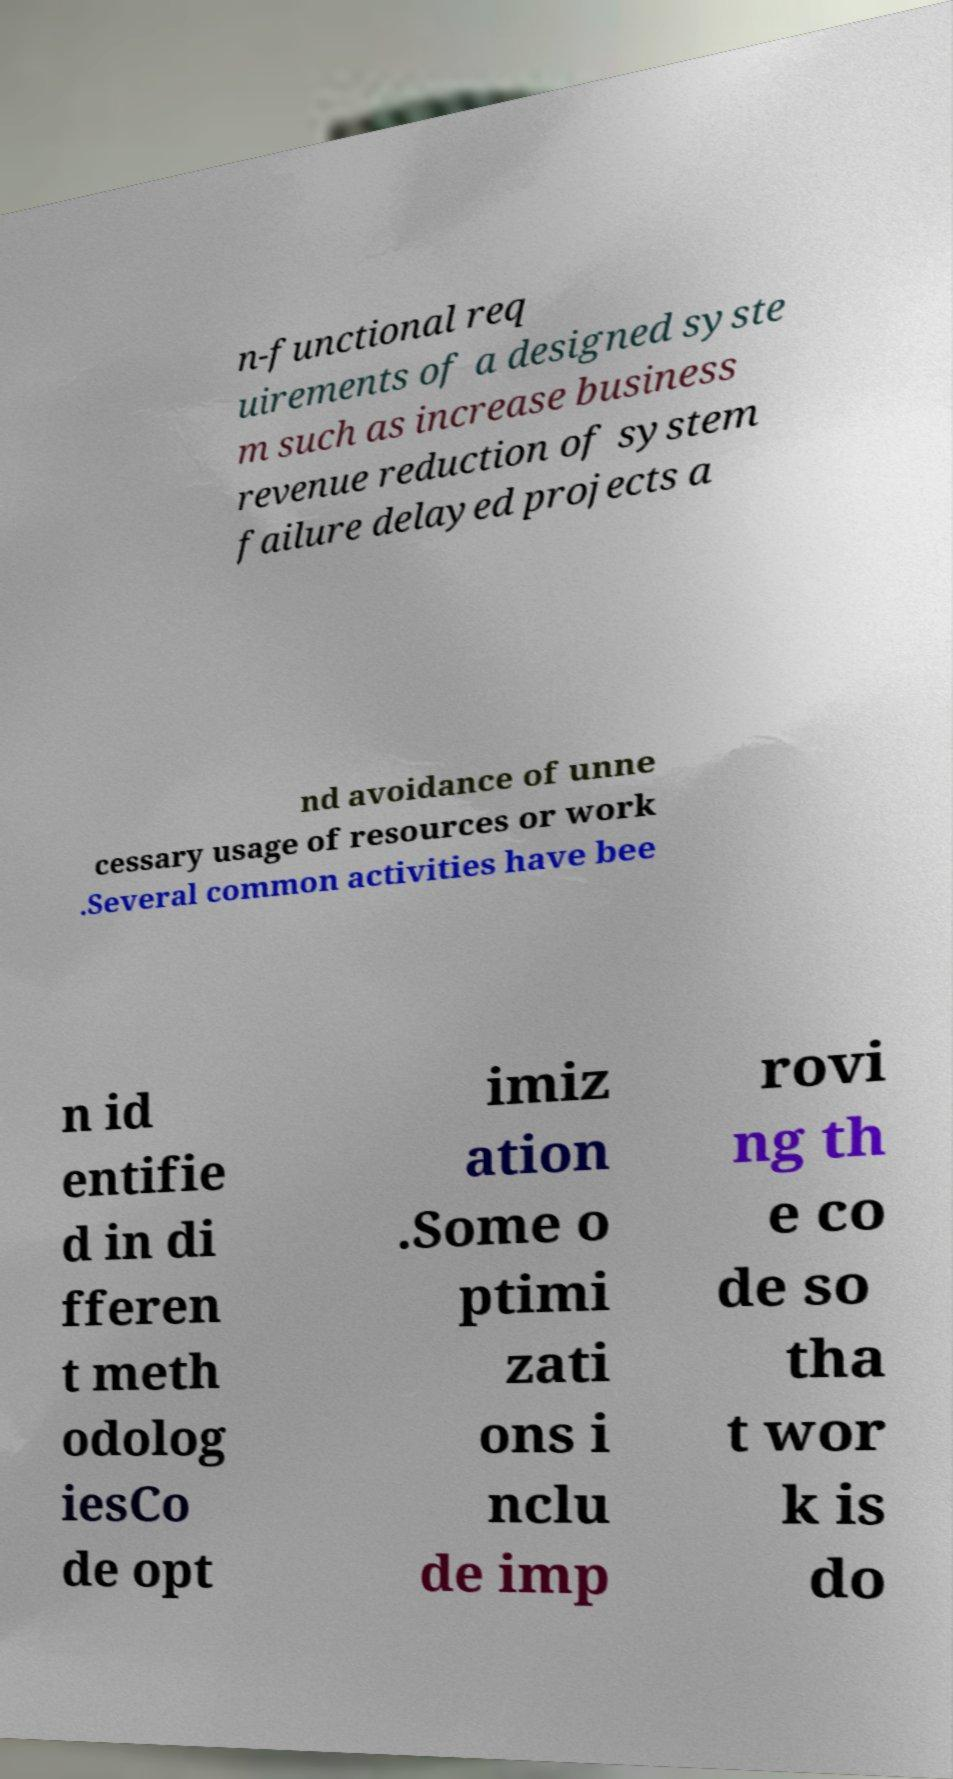Could you assist in decoding the text presented in this image and type it out clearly? n-functional req uirements of a designed syste m such as increase business revenue reduction of system failure delayed projects a nd avoidance of unne cessary usage of resources or work .Several common activities have bee n id entifie d in di fferen t meth odolog iesCo de opt imiz ation .Some o ptimi zati ons i nclu de imp rovi ng th e co de so tha t wor k is do 